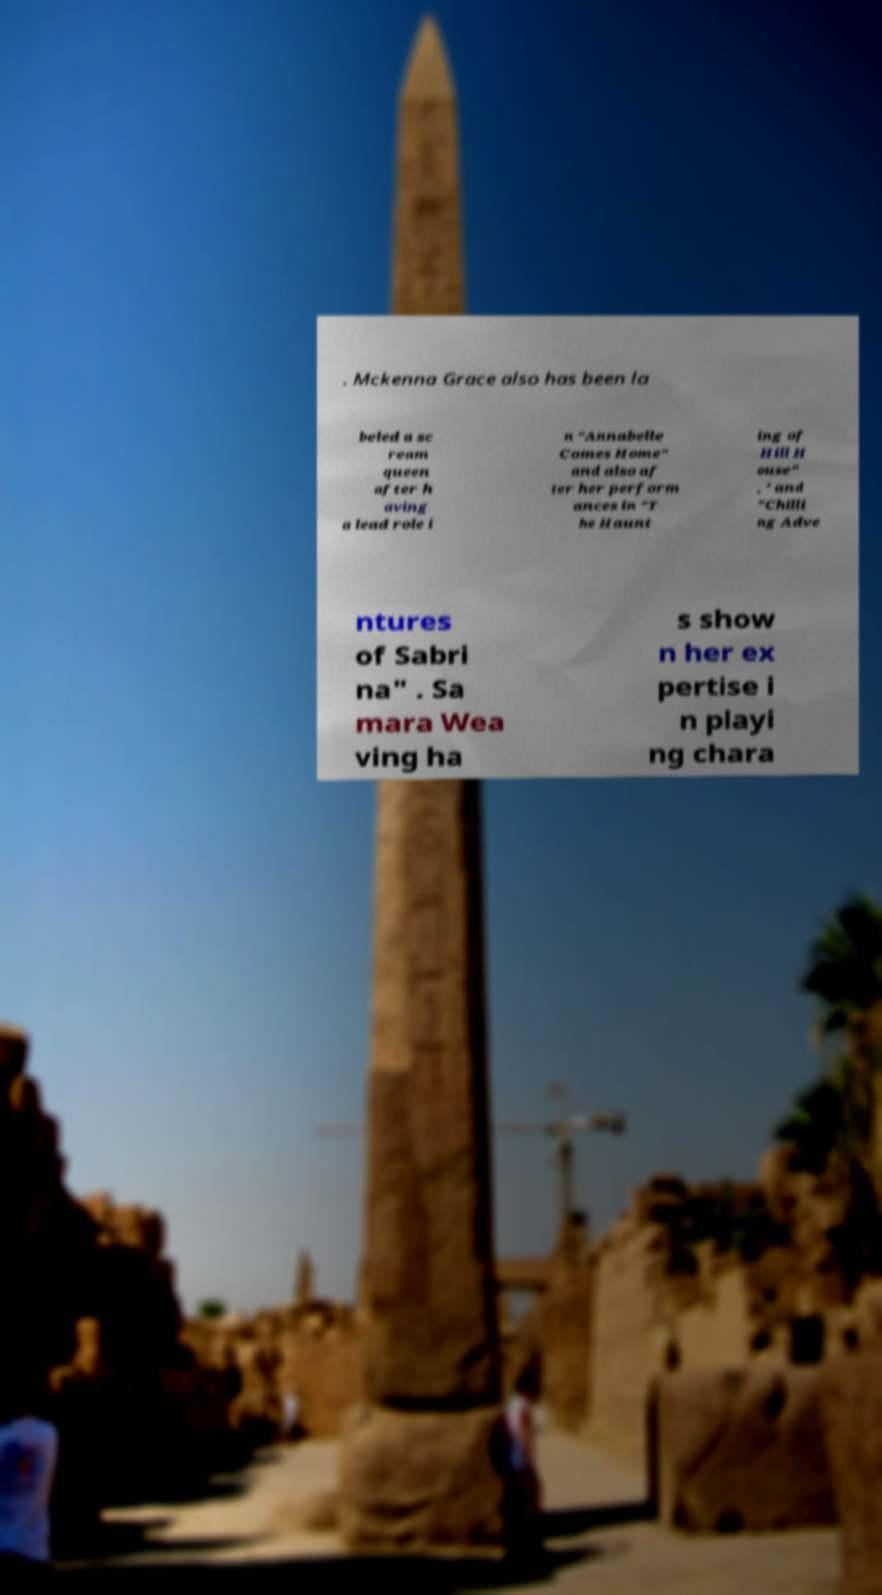Please identify and transcribe the text found in this image. . Mckenna Grace also has been la beled a sc ream queen after h aving a lead role i n "Annabelle Comes Home" and also af ter her perform ances in "T he Haunt ing of Hill H ouse" , ' and "Chilli ng Adve ntures of Sabri na" . Sa mara Wea ving ha s show n her ex pertise i n playi ng chara 